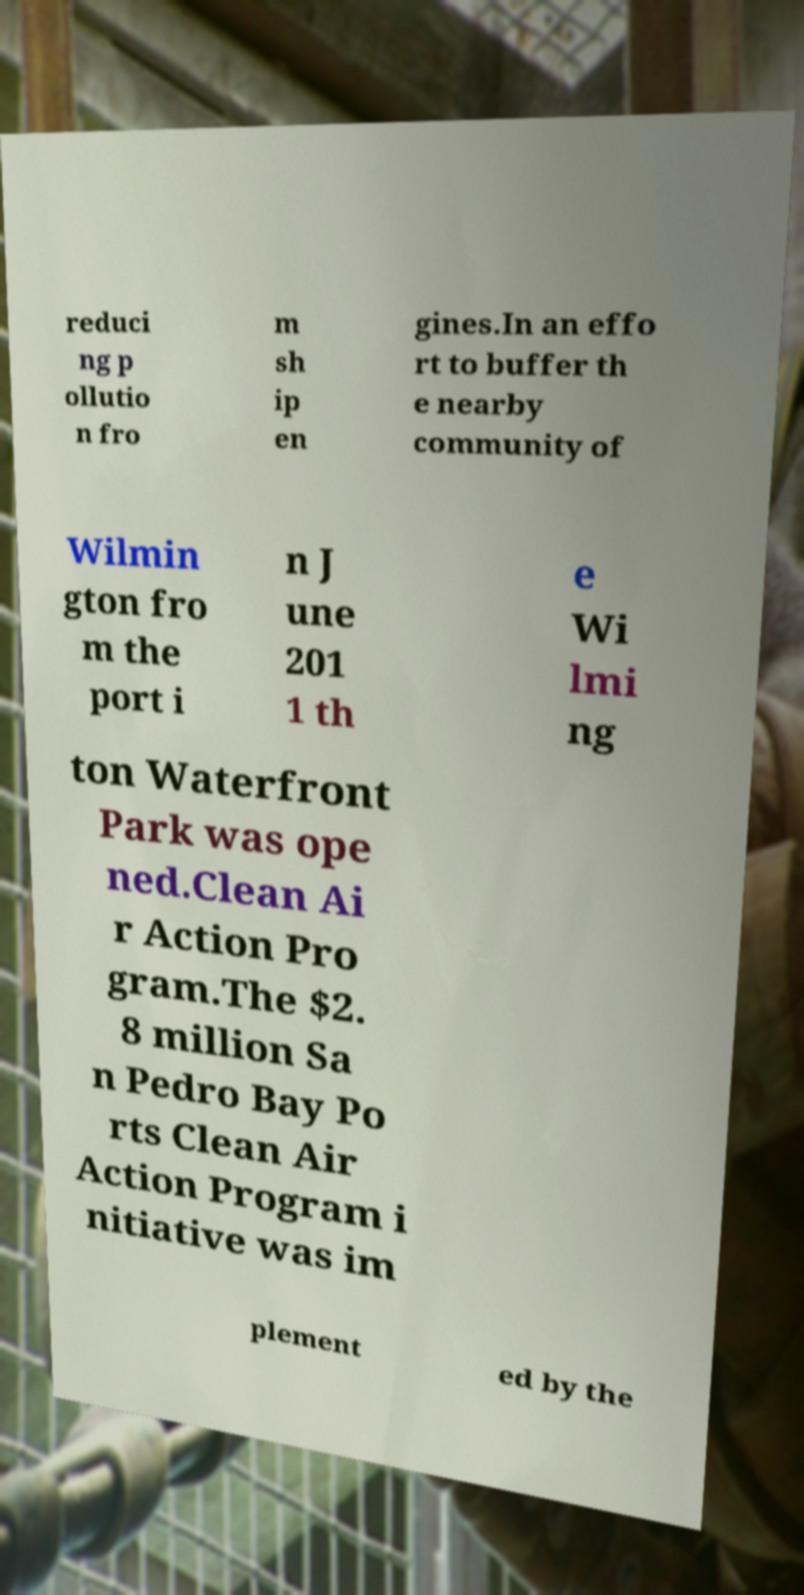Could you assist in decoding the text presented in this image and type it out clearly? reduci ng p ollutio n fro m sh ip en gines.In an effo rt to buffer th e nearby community of Wilmin gton fro m the port i n J une 201 1 th e Wi lmi ng ton Waterfront Park was ope ned.Clean Ai r Action Pro gram.The $2. 8 million Sa n Pedro Bay Po rts Clean Air Action Program i nitiative was im plement ed by the 